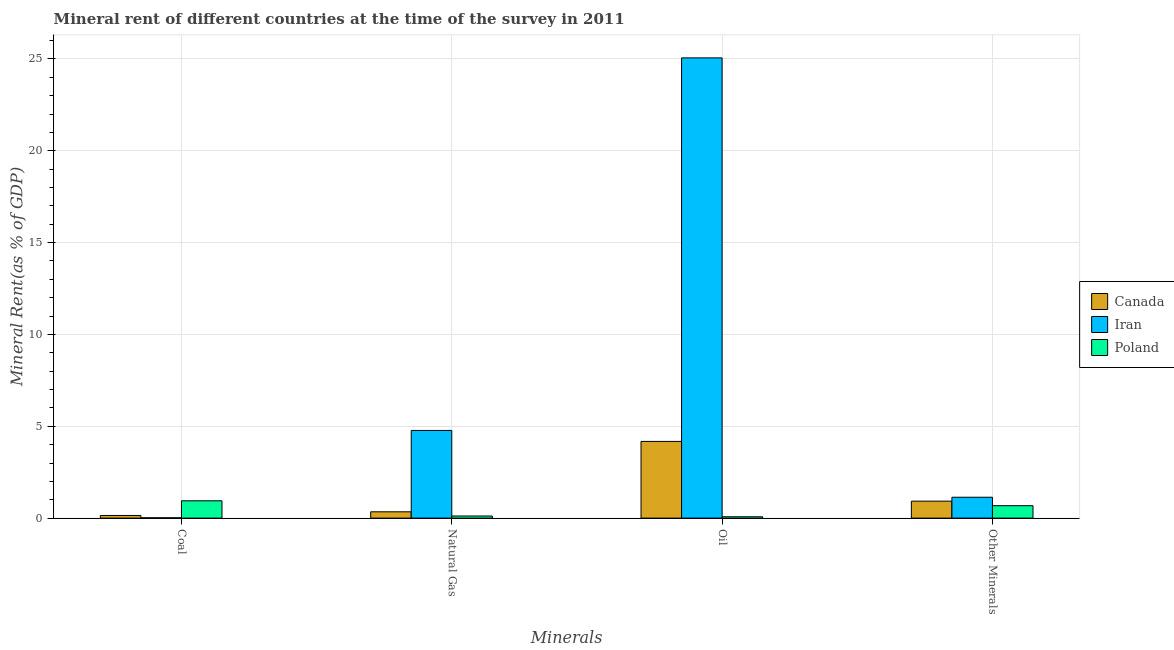How many different coloured bars are there?
Keep it short and to the point. 3. What is the label of the 2nd group of bars from the left?
Offer a very short reply. Natural Gas. What is the coal rent in Iran?
Ensure brevity in your answer.  0.02. Across all countries, what is the maximum coal rent?
Provide a short and direct response. 0.94. Across all countries, what is the minimum  rent of other minerals?
Ensure brevity in your answer.  0.68. In which country was the coal rent maximum?
Make the answer very short. Poland. In which country was the oil rent minimum?
Your answer should be very brief. Poland. What is the total oil rent in the graph?
Keep it short and to the point. 29.31. What is the difference between the oil rent in Poland and that in Iran?
Keep it short and to the point. -24.98. What is the difference between the  rent of other minerals in Iran and the oil rent in Canada?
Your answer should be compact. -3.04. What is the average coal rent per country?
Your response must be concise. 0.37. What is the difference between the natural gas rent and oil rent in Iran?
Ensure brevity in your answer.  -20.28. In how many countries, is the oil rent greater than 12 %?
Offer a terse response. 1. What is the ratio of the coal rent in Canada to that in Iran?
Your response must be concise. 7.87. Is the  rent of other minerals in Iran less than that in Poland?
Your answer should be compact. No. Is the difference between the  rent of other minerals in Iran and Canada greater than the difference between the coal rent in Iran and Canada?
Keep it short and to the point. Yes. What is the difference between the highest and the second highest  rent of other minerals?
Provide a short and direct response. 0.21. What is the difference between the highest and the lowest coal rent?
Offer a terse response. 0.92. In how many countries, is the natural gas rent greater than the average natural gas rent taken over all countries?
Your answer should be very brief. 1. Is the sum of the natural gas rent in Poland and Iran greater than the maximum  rent of other minerals across all countries?
Give a very brief answer. Yes. Is it the case that in every country, the sum of the  rent of other minerals and coal rent is greater than the sum of natural gas rent and oil rent?
Keep it short and to the point. Yes. What does the 1st bar from the left in Other Minerals represents?
Offer a very short reply. Canada. How many countries are there in the graph?
Keep it short and to the point. 3. How many legend labels are there?
Provide a short and direct response. 3. What is the title of the graph?
Keep it short and to the point. Mineral rent of different countries at the time of the survey in 2011. What is the label or title of the X-axis?
Provide a short and direct response. Minerals. What is the label or title of the Y-axis?
Ensure brevity in your answer.  Mineral Rent(as % of GDP). What is the Mineral Rent(as % of GDP) of Canada in Coal?
Offer a terse response. 0.14. What is the Mineral Rent(as % of GDP) in Iran in Coal?
Make the answer very short. 0.02. What is the Mineral Rent(as % of GDP) in Poland in Coal?
Provide a short and direct response. 0.94. What is the Mineral Rent(as % of GDP) of Canada in Natural Gas?
Keep it short and to the point. 0.34. What is the Mineral Rent(as % of GDP) of Iran in Natural Gas?
Your answer should be compact. 4.77. What is the Mineral Rent(as % of GDP) of Poland in Natural Gas?
Your answer should be very brief. 0.12. What is the Mineral Rent(as % of GDP) of Canada in Oil?
Offer a very short reply. 4.18. What is the Mineral Rent(as % of GDP) in Iran in Oil?
Provide a short and direct response. 25.06. What is the Mineral Rent(as % of GDP) in Poland in Oil?
Your answer should be compact. 0.07. What is the Mineral Rent(as % of GDP) of Canada in Other Minerals?
Your answer should be compact. 0.92. What is the Mineral Rent(as % of GDP) in Iran in Other Minerals?
Provide a succinct answer. 1.14. What is the Mineral Rent(as % of GDP) in Poland in Other Minerals?
Give a very brief answer. 0.68. Across all Minerals, what is the maximum Mineral Rent(as % of GDP) in Canada?
Provide a succinct answer. 4.18. Across all Minerals, what is the maximum Mineral Rent(as % of GDP) in Iran?
Provide a short and direct response. 25.06. Across all Minerals, what is the maximum Mineral Rent(as % of GDP) of Poland?
Your answer should be very brief. 0.94. Across all Minerals, what is the minimum Mineral Rent(as % of GDP) of Canada?
Provide a succinct answer. 0.14. Across all Minerals, what is the minimum Mineral Rent(as % of GDP) in Iran?
Your answer should be compact. 0.02. Across all Minerals, what is the minimum Mineral Rent(as % of GDP) of Poland?
Make the answer very short. 0.07. What is the total Mineral Rent(as % of GDP) of Canada in the graph?
Offer a very short reply. 5.59. What is the total Mineral Rent(as % of GDP) of Iran in the graph?
Your answer should be compact. 30.98. What is the total Mineral Rent(as % of GDP) in Poland in the graph?
Your answer should be compact. 1.81. What is the difference between the Mineral Rent(as % of GDP) in Iran in Coal and that in Natural Gas?
Offer a very short reply. -4.75. What is the difference between the Mineral Rent(as % of GDP) in Poland in Coal and that in Natural Gas?
Ensure brevity in your answer.  0.83. What is the difference between the Mineral Rent(as % of GDP) in Canada in Coal and that in Oil?
Provide a short and direct response. -4.03. What is the difference between the Mineral Rent(as % of GDP) of Iran in Coal and that in Oil?
Keep it short and to the point. -25.04. What is the difference between the Mineral Rent(as % of GDP) in Poland in Coal and that in Oil?
Provide a short and direct response. 0.87. What is the difference between the Mineral Rent(as % of GDP) of Canada in Coal and that in Other Minerals?
Your response must be concise. -0.78. What is the difference between the Mineral Rent(as % of GDP) in Iran in Coal and that in Other Minerals?
Provide a succinct answer. -1.12. What is the difference between the Mineral Rent(as % of GDP) in Poland in Coal and that in Other Minerals?
Ensure brevity in your answer.  0.27. What is the difference between the Mineral Rent(as % of GDP) of Canada in Natural Gas and that in Oil?
Your response must be concise. -3.83. What is the difference between the Mineral Rent(as % of GDP) in Iran in Natural Gas and that in Oil?
Keep it short and to the point. -20.28. What is the difference between the Mineral Rent(as % of GDP) of Poland in Natural Gas and that in Oil?
Provide a short and direct response. 0.04. What is the difference between the Mineral Rent(as % of GDP) in Canada in Natural Gas and that in Other Minerals?
Provide a succinct answer. -0.58. What is the difference between the Mineral Rent(as % of GDP) in Iran in Natural Gas and that in Other Minerals?
Your answer should be very brief. 3.64. What is the difference between the Mineral Rent(as % of GDP) of Poland in Natural Gas and that in Other Minerals?
Your answer should be compact. -0.56. What is the difference between the Mineral Rent(as % of GDP) of Canada in Oil and that in Other Minerals?
Your answer should be compact. 3.25. What is the difference between the Mineral Rent(as % of GDP) in Iran in Oil and that in Other Minerals?
Offer a terse response. 23.92. What is the difference between the Mineral Rent(as % of GDP) in Poland in Oil and that in Other Minerals?
Ensure brevity in your answer.  -0.6. What is the difference between the Mineral Rent(as % of GDP) of Canada in Coal and the Mineral Rent(as % of GDP) of Iran in Natural Gas?
Provide a succinct answer. -4.63. What is the difference between the Mineral Rent(as % of GDP) of Canada in Coal and the Mineral Rent(as % of GDP) of Poland in Natural Gas?
Your answer should be very brief. 0.03. What is the difference between the Mineral Rent(as % of GDP) of Iran in Coal and the Mineral Rent(as % of GDP) of Poland in Natural Gas?
Your response must be concise. -0.1. What is the difference between the Mineral Rent(as % of GDP) in Canada in Coal and the Mineral Rent(as % of GDP) in Iran in Oil?
Your response must be concise. -24.91. What is the difference between the Mineral Rent(as % of GDP) of Canada in Coal and the Mineral Rent(as % of GDP) of Poland in Oil?
Your answer should be very brief. 0.07. What is the difference between the Mineral Rent(as % of GDP) in Iran in Coal and the Mineral Rent(as % of GDP) in Poland in Oil?
Your answer should be very brief. -0.05. What is the difference between the Mineral Rent(as % of GDP) in Canada in Coal and the Mineral Rent(as % of GDP) in Iran in Other Minerals?
Give a very brief answer. -0.99. What is the difference between the Mineral Rent(as % of GDP) in Canada in Coal and the Mineral Rent(as % of GDP) in Poland in Other Minerals?
Keep it short and to the point. -0.53. What is the difference between the Mineral Rent(as % of GDP) of Iran in Coal and the Mineral Rent(as % of GDP) of Poland in Other Minerals?
Provide a short and direct response. -0.66. What is the difference between the Mineral Rent(as % of GDP) of Canada in Natural Gas and the Mineral Rent(as % of GDP) of Iran in Oil?
Your answer should be very brief. -24.71. What is the difference between the Mineral Rent(as % of GDP) in Canada in Natural Gas and the Mineral Rent(as % of GDP) in Poland in Oil?
Make the answer very short. 0.27. What is the difference between the Mineral Rent(as % of GDP) in Iran in Natural Gas and the Mineral Rent(as % of GDP) in Poland in Oil?
Your answer should be compact. 4.7. What is the difference between the Mineral Rent(as % of GDP) of Canada in Natural Gas and the Mineral Rent(as % of GDP) of Iran in Other Minerals?
Your answer should be very brief. -0.79. What is the difference between the Mineral Rent(as % of GDP) of Canada in Natural Gas and the Mineral Rent(as % of GDP) of Poland in Other Minerals?
Provide a short and direct response. -0.33. What is the difference between the Mineral Rent(as % of GDP) in Iran in Natural Gas and the Mineral Rent(as % of GDP) in Poland in Other Minerals?
Give a very brief answer. 4.1. What is the difference between the Mineral Rent(as % of GDP) of Canada in Oil and the Mineral Rent(as % of GDP) of Iran in Other Minerals?
Provide a short and direct response. 3.04. What is the difference between the Mineral Rent(as % of GDP) in Canada in Oil and the Mineral Rent(as % of GDP) in Poland in Other Minerals?
Offer a terse response. 3.5. What is the difference between the Mineral Rent(as % of GDP) in Iran in Oil and the Mineral Rent(as % of GDP) in Poland in Other Minerals?
Make the answer very short. 24.38. What is the average Mineral Rent(as % of GDP) of Canada per Minerals?
Offer a very short reply. 1.4. What is the average Mineral Rent(as % of GDP) in Iran per Minerals?
Keep it short and to the point. 7.75. What is the average Mineral Rent(as % of GDP) in Poland per Minerals?
Offer a very short reply. 0.45. What is the difference between the Mineral Rent(as % of GDP) of Canada and Mineral Rent(as % of GDP) of Iran in Coal?
Your answer should be very brief. 0.13. What is the difference between the Mineral Rent(as % of GDP) of Canada and Mineral Rent(as % of GDP) of Poland in Coal?
Your answer should be compact. -0.8. What is the difference between the Mineral Rent(as % of GDP) in Iran and Mineral Rent(as % of GDP) in Poland in Coal?
Offer a terse response. -0.92. What is the difference between the Mineral Rent(as % of GDP) of Canada and Mineral Rent(as % of GDP) of Iran in Natural Gas?
Provide a short and direct response. -4.43. What is the difference between the Mineral Rent(as % of GDP) in Canada and Mineral Rent(as % of GDP) in Poland in Natural Gas?
Make the answer very short. 0.23. What is the difference between the Mineral Rent(as % of GDP) of Iran and Mineral Rent(as % of GDP) of Poland in Natural Gas?
Ensure brevity in your answer.  4.66. What is the difference between the Mineral Rent(as % of GDP) in Canada and Mineral Rent(as % of GDP) in Iran in Oil?
Offer a terse response. -20.88. What is the difference between the Mineral Rent(as % of GDP) in Canada and Mineral Rent(as % of GDP) in Poland in Oil?
Your response must be concise. 4.1. What is the difference between the Mineral Rent(as % of GDP) in Iran and Mineral Rent(as % of GDP) in Poland in Oil?
Offer a very short reply. 24.98. What is the difference between the Mineral Rent(as % of GDP) of Canada and Mineral Rent(as % of GDP) of Iran in Other Minerals?
Give a very brief answer. -0.21. What is the difference between the Mineral Rent(as % of GDP) of Canada and Mineral Rent(as % of GDP) of Poland in Other Minerals?
Ensure brevity in your answer.  0.25. What is the difference between the Mineral Rent(as % of GDP) of Iran and Mineral Rent(as % of GDP) of Poland in Other Minerals?
Provide a short and direct response. 0.46. What is the ratio of the Mineral Rent(as % of GDP) of Canada in Coal to that in Natural Gas?
Keep it short and to the point. 0.42. What is the ratio of the Mineral Rent(as % of GDP) in Iran in Coal to that in Natural Gas?
Keep it short and to the point. 0. What is the ratio of the Mineral Rent(as % of GDP) in Poland in Coal to that in Natural Gas?
Offer a terse response. 8.11. What is the ratio of the Mineral Rent(as % of GDP) of Canada in Coal to that in Oil?
Your answer should be compact. 0.03. What is the ratio of the Mineral Rent(as % of GDP) in Iran in Coal to that in Oil?
Provide a short and direct response. 0. What is the ratio of the Mineral Rent(as % of GDP) of Poland in Coal to that in Oil?
Provide a short and direct response. 12.91. What is the ratio of the Mineral Rent(as % of GDP) of Canada in Coal to that in Other Minerals?
Your answer should be very brief. 0.16. What is the ratio of the Mineral Rent(as % of GDP) of Iran in Coal to that in Other Minerals?
Make the answer very short. 0.02. What is the ratio of the Mineral Rent(as % of GDP) in Poland in Coal to that in Other Minerals?
Offer a very short reply. 1.39. What is the ratio of the Mineral Rent(as % of GDP) of Canada in Natural Gas to that in Oil?
Give a very brief answer. 0.08. What is the ratio of the Mineral Rent(as % of GDP) of Iran in Natural Gas to that in Oil?
Ensure brevity in your answer.  0.19. What is the ratio of the Mineral Rent(as % of GDP) in Poland in Natural Gas to that in Oil?
Offer a very short reply. 1.59. What is the ratio of the Mineral Rent(as % of GDP) of Canada in Natural Gas to that in Other Minerals?
Keep it short and to the point. 0.37. What is the ratio of the Mineral Rent(as % of GDP) in Iran in Natural Gas to that in Other Minerals?
Offer a terse response. 4.2. What is the ratio of the Mineral Rent(as % of GDP) in Poland in Natural Gas to that in Other Minerals?
Provide a short and direct response. 0.17. What is the ratio of the Mineral Rent(as % of GDP) of Canada in Oil to that in Other Minerals?
Keep it short and to the point. 4.52. What is the ratio of the Mineral Rent(as % of GDP) in Iran in Oil to that in Other Minerals?
Your answer should be compact. 22.05. What is the ratio of the Mineral Rent(as % of GDP) of Poland in Oil to that in Other Minerals?
Provide a short and direct response. 0.11. What is the difference between the highest and the second highest Mineral Rent(as % of GDP) in Canada?
Keep it short and to the point. 3.25. What is the difference between the highest and the second highest Mineral Rent(as % of GDP) in Iran?
Offer a terse response. 20.28. What is the difference between the highest and the second highest Mineral Rent(as % of GDP) of Poland?
Make the answer very short. 0.27. What is the difference between the highest and the lowest Mineral Rent(as % of GDP) in Canada?
Your answer should be very brief. 4.03. What is the difference between the highest and the lowest Mineral Rent(as % of GDP) of Iran?
Ensure brevity in your answer.  25.04. What is the difference between the highest and the lowest Mineral Rent(as % of GDP) in Poland?
Give a very brief answer. 0.87. 